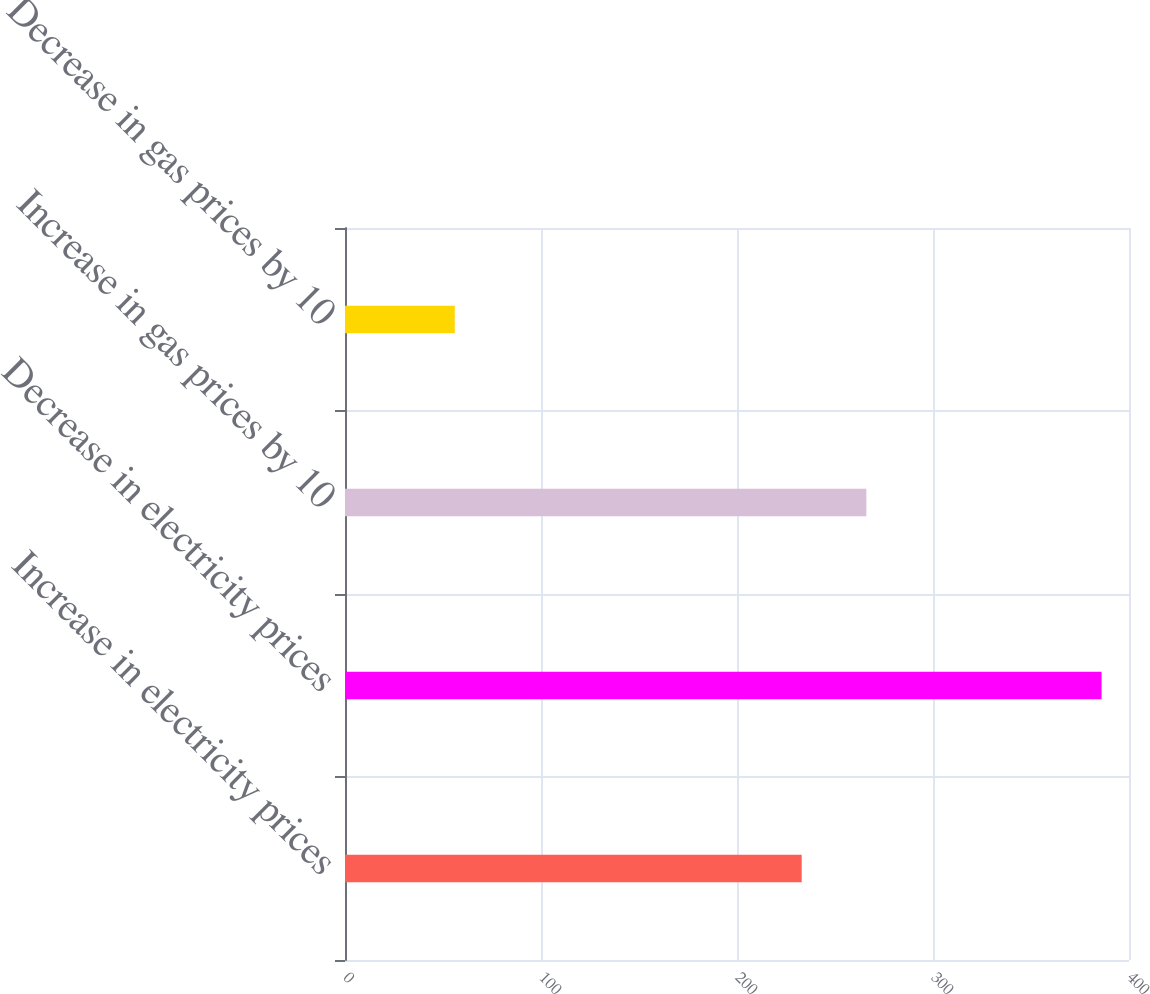Convert chart. <chart><loc_0><loc_0><loc_500><loc_500><bar_chart><fcel>Increase in electricity prices<fcel>Decrease in electricity prices<fcel>Increase in gas prices by 10<fcel>Decrease in gas prices by 10<nl><fcel>233<fcel>386<fcel>266<fcel>56<nl></chart> 